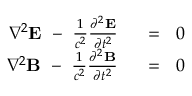<formula> <loc_0><loc_0><loc_500><loc_500>{ \begin{array} { r l } { \nabla ^ { 2 } E \ - \ { \frac { 1 } { c ^ { 2 } } } { \frac { \partial ^ { 2 } E } { \partial t ^ { 2 } } } \ \ } & { = \ \ 0 } \\ { \nabla ^ { 2 } B \ - \ { \frac { 1 } { c ^ { 2 } } } { \frac { \partial ^ { 2 } B } { \partial t ^ { 2 } } } \ \ } & { = \ \ 0 } \end{array} }</formula> 